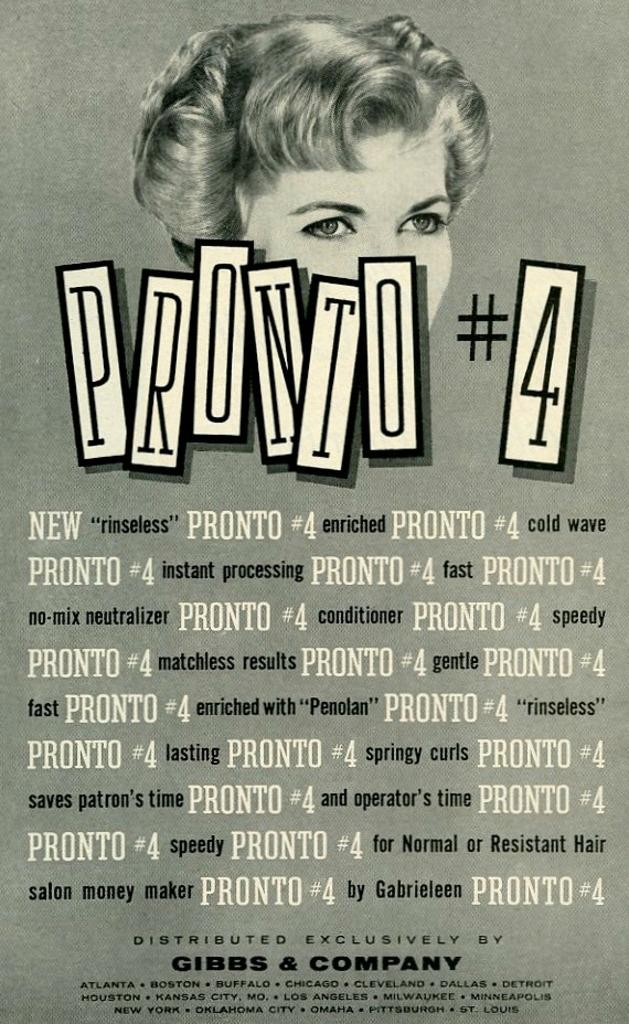Provide a one-sentence caption for the provided image. A Gibbs & Company poster featuring Pronto # 4 with a woman pictured behind the title. 